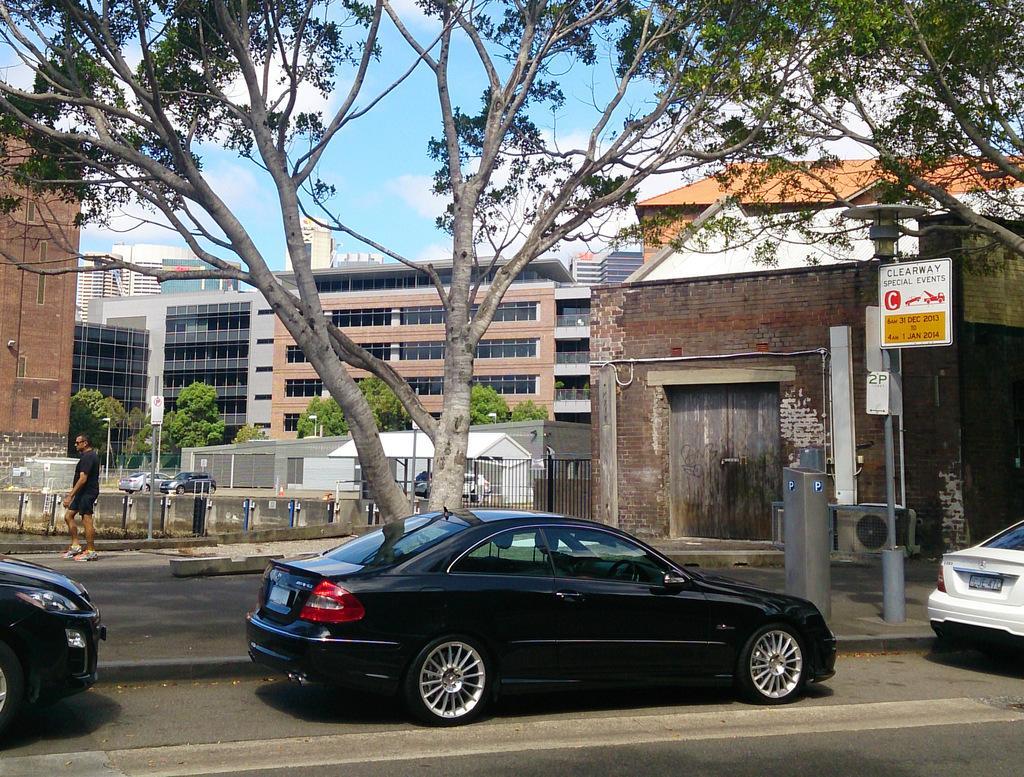Please provide a concise description of this image. In this image we can see buildings, trees, fence, vehicles, board and we can also see a man walking. 